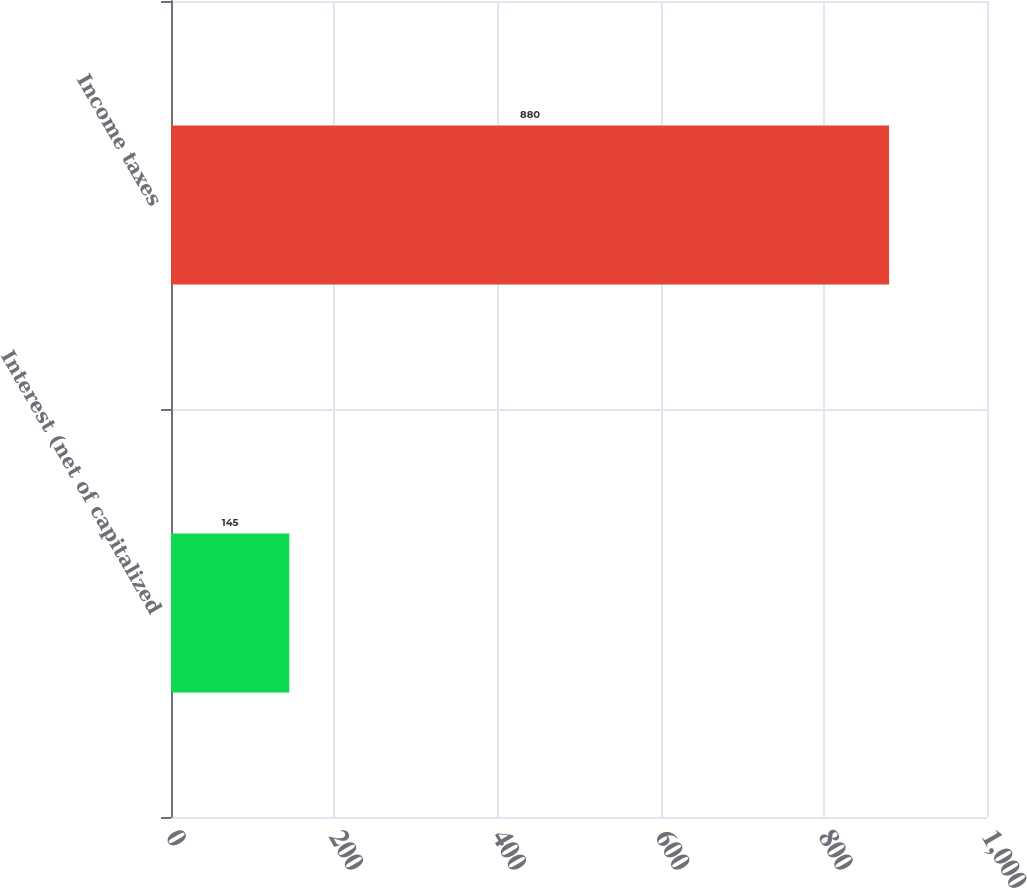Convert chart. <chart><loc_0><loc_0><loc_500><loc_500><bar_chart><fcel>Interest (net of capitalized<fcel>Income taxes<nl><fcel>145<fcel>880<nl></chart> 